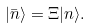Convert formula to latex. <formula><loc_0><loc_0><loc_500><loc_500>| \bar { n } \rangle = \Xi | n \rangle .</formula> 